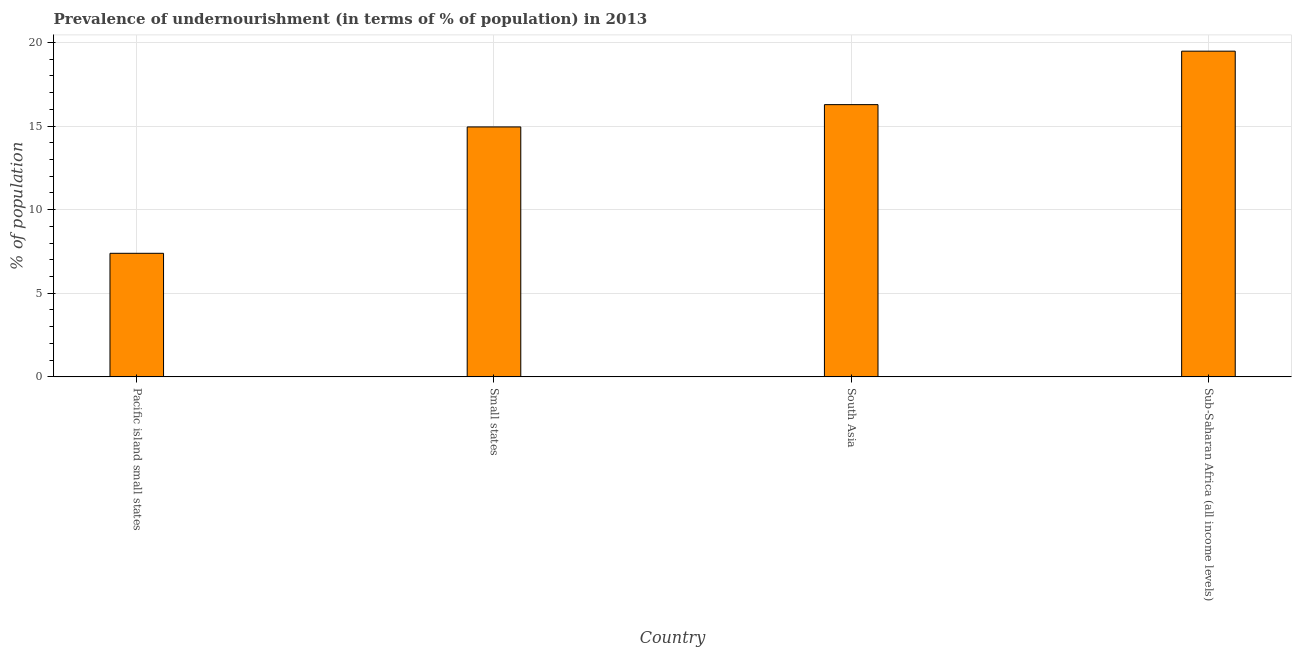What is the title of the graph?
Your answer should be compact. Prevalence of undernourishment (in terms of % of population) in 2013. What is the label or title of the X-axis?
Provide a short and direct response. Country. What is the label or title of the Y-axis?
Your response must be concise. % of population. What is the percentage of undernourished population in Small states?
Provide a succinct answer. 14.95. Across all countries, what is the maximum percentage of undernourished population?
Offer a terse response. 19.48. Across all countries, what is the minimum percentage of undernourished population?
Your answer should be compact. 7.39. In which country was the percentage of undernourished population maximum?
Keep it short and to the point. Sub-Saharan Africa (all income levels). In which country was the percentage of undernourished population minimum?
Give a very brief answer. Pacific island small states. What is the sum of the percentage of undernourished population?
Your answer should be compact. 58.09. What is the difference between the percentage of undernourished population in South Asia and Sub-Saharan Africa (all income levels)?
Your response must be concise. -3.2. What is the average percentage of undernourished population per country?
Your answer should be very brief. 14.52. What is the median percentage of undernourished population?
Ensure brevity in your answer.  15.61. What is the ratio of the percentage of undernourished population in South Asia to that in Sub-Saharan Africa (all income levels)?
Give a very brief answer. 0.84. What is the difference between the highest and the second highest percentage of undernourished population?
Offer a terse response. 3.2. Is the sum of the percentage of undernourished population in Small states and Sub-Saharan Africa (all income levels) greater than the maximum percentage of undernourished population across all countries?
Ensure brevity in your answer.  Yes. What is the difference between the highest and the lowest percentage of undernourished population?
Ensure brevity in your answer.  12.09. In how many countries, is the percentage of undernourished population greater than the average percentage of undernourished population taken over all countries?
Keep it short and to the point. 3. How many countries are there in the graph?
Offer a very short reply. 4. What is the difference between two consecutive major ticks on the Y-axis?
Your answer should be compact. 5. What is the % of population of Pacific island small states?
Give a very brief answer. 7.39. What is the % of population in Small states?
Your answer should be compact. 14.95. What is the % of population of South Asia?
Keep it short and to the point. 16.28. What is the % of population of Sub-Saharan Africa (all income levels)?
Your answer should be compact. 19.48. What is the difference between the % of population in Pacific island small states and Small states?
Keep it short and to the point. -7.56. What is the difference between the % of population in Pacific island small states and South Asia?
Provide a succinct answer. -8.89. What is the difference between the % of population in Pacific island small states and Sub-Saharan Africa (all income levels)?
Provide a succinct answer. -12.09. What is the difference between the % of population in Small states and South Asia?
Provide a short and direct response. -1.33. What is the difference between the % of population in Small states and Sub-Saharan Africa (all income levels)?
Ensure brevity in your answer.  -4.53. What is the difference between the % of population in South Asia and Sub-Saharan Africa (all income levels)?
Offer a very short reply. -3.2. What is the ratio of the % of population in Pacific island small states to that in Small states?
Provide a succinct answer. 0.49. What is the ratio of the % of population in Pacific island small states to that in South Asia?
Your answer should be very brief. 0.45. What is the ratio of the % of population in Pacific island small states to that in Sub-Saharan Africa (all income levels)?
Your answer should be very brief. 0.38. What is the ratio of the % of population in Small states to that in South Asia?
Your answer should be compact. 0.92. What is the ratio of the % of population in Small states to that in Sub-Saharan Africa (all income levels)?
Your answer should be compact. 0.77. What is the ratio of the % of population in South Asia to that in Sub-Saharan Africa (all income levels)?
Your answer should be very brief. 0.84. 